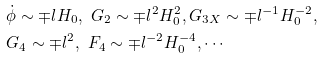Convert formula to latex. <formula><loc_0><loc_0><loc_500><loc_500>& \dot { \phi } \sim \mp l H _ { 0 } , \ G _ { 2 } \sim \mp l ^ { 2 } H _ { 0 } ^ { 2 } , G _ { 3 X } \sim \mp l ^ { - 1 } H _ { 0 } ^ { - 2 } , \\ & G _ { 4 } \sim \mp l ^ { 2 } , \ F _ { 4 } \sim \mp l ^ { - 2 } H ^ { - 4 } _ { 0 } , \cdots</formula> 